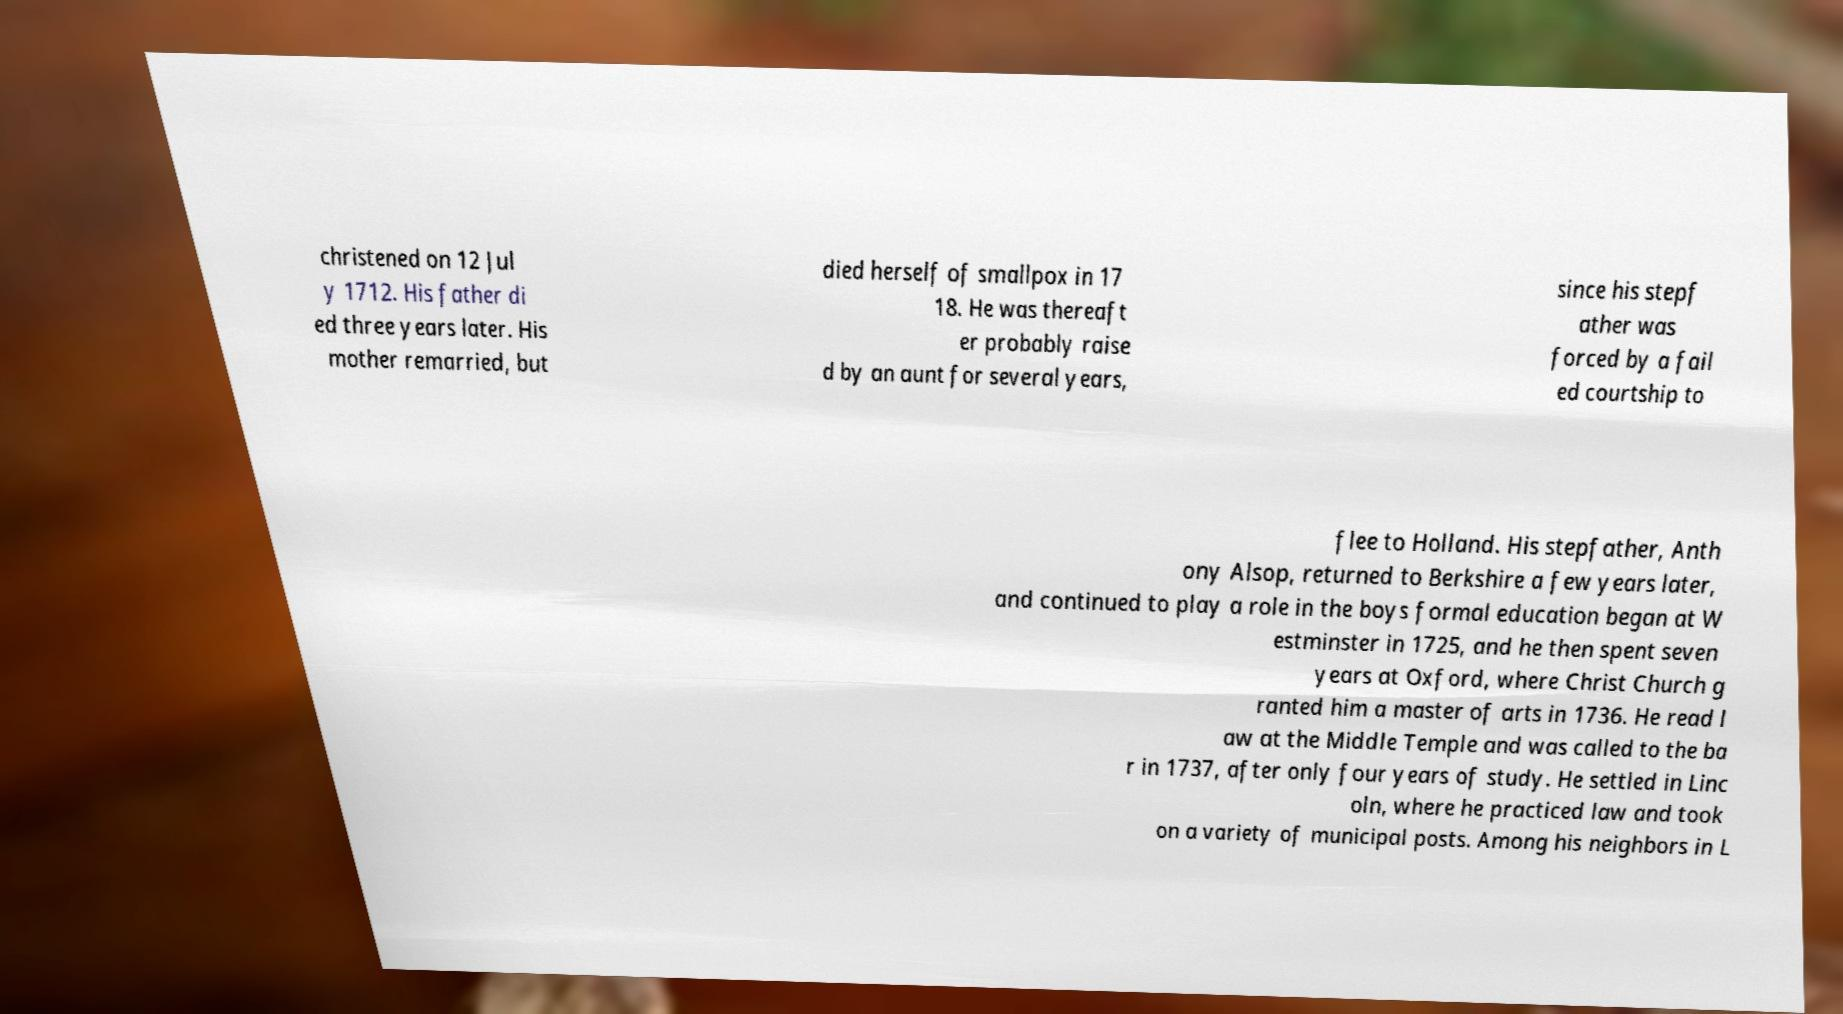Can you read and provide the text displayed in the image?This photo seems to have some interesting text. Can you extract and type it out for me? christened on 12 Jul y 1712. His father di ed three years later. His mother remarried, but died herself of smallpox in 17 18. He was thereaft er probably raise d by an aunt for several years, since his stepf ather was forced by a fail ed courtship to flee to Holland. His stepfather, Anth ony Alsop, returned to Berkshire a few years later, and continued to play a role in the boys formal education began at W estminster in 1725, and he then spent seven years at Oxford, where Christ Church g ranted him a master of arts in 1736. He read l aw at the Middle Temple and was called to the ba r in 1737, after only four years of study. He settled in Linc oln, where he practiced law and took on a variety of municipal posts. Among his neighbors in L 